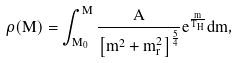Convert formula to latex. <formula><loc_0><loc_0><loc_500><loc_500>\rho ( M ) = \int _ { M _ { 0 } } ^ { M } \frac { A } { \left [ m ^ { 2 } + m _ { r } ^ { 2 } \right ] ^ { \frac { 5 } { 4 } } } e ^ { \frac { m } { T _ { H } } } d m ,</formula> 